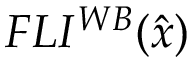Convert formula to latex. <formula><loc_0><loc_0><loc_500><loc_500>F L I ^ { W B } ( \hat { x } )</formula> 